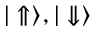Convert formula to latex. <formula><loc_0><loc_0><loc_500><loc_500>{ | \Uparrow \rangle } , { | \Downarrow \rangle }</formula> 